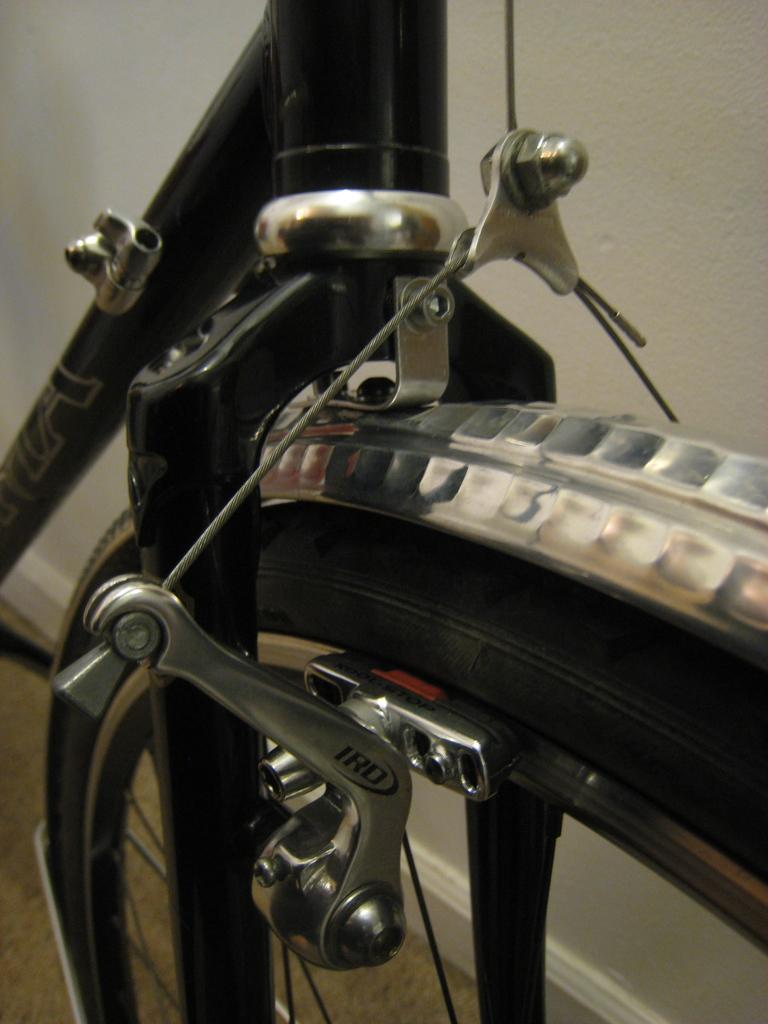What is the main object in the image? There is a bicycle in the image. What colors can be seen on the bicycle? The bicycle is black and silver in color. Where is the bicycle located in the image? The bicycle is on the floor. What is the color of the floor? The floor is brown in color. What can be seen in the background of the image? There is a wall in the background of the image. What is the color of the wall? The wall is white in color. What type of lunchroom is depicted in the image? There is no lunchroom present in the image; it features a bicycle on the floor. What kind of club is associated with the bicycle in the image? There is no club associated with the bicycle in the image. 